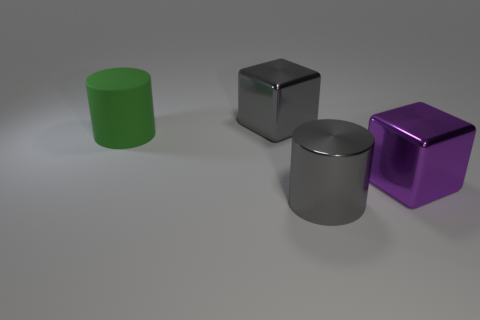Add 2 green rubber objects. How many objects exist? 6 Subtract all green cylinders. How many cylinders are left? 1 Subtract 0 green balls. How many objects are left? 4 Subtract 1 cylinders. How many cylinders are left? 1 Subtract all purple blocks. Subtract all yellow cylinders. How many blocks are left? 1 Subtract all blue spheres. How many green cylinders are left? 1 Subtract all cylinders. Subtract all cylinders. How many objects are left? 0 Add 3 large gray metallic cylinders. How many large gray metallic cylinders are left? 4 Add 1 gray blocks. How many gray blocks exist? 2 